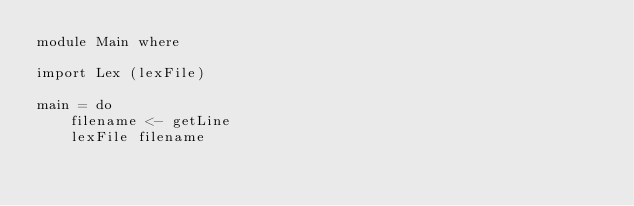<code> <loc_0><loc_0><loc_500><loc_500><_Haskell_>module Main where

import Lex (lexFile)

main = do
    filename <- getLine
    lexFile filename
</code> 